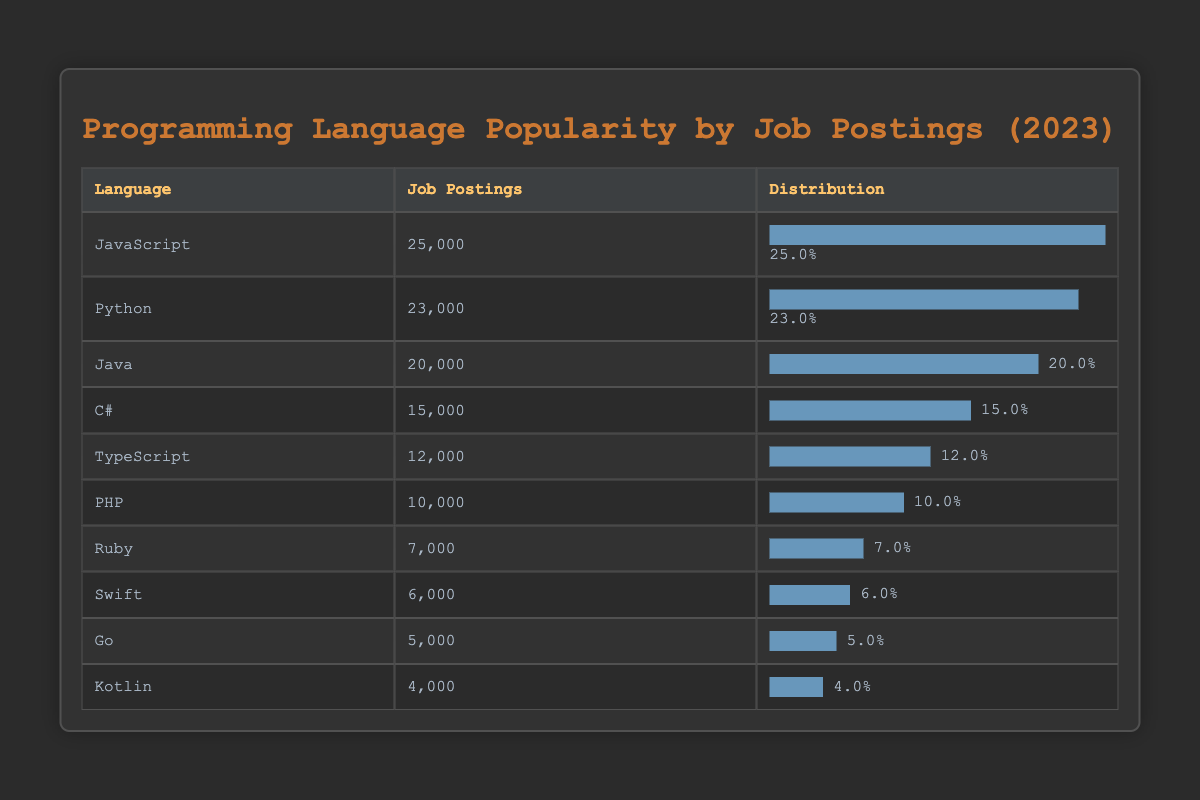What is the programming language with the most job postings? The table shows that JavaScript has 25,000 job postings, which is the highest among all listed languages.
Answer: JavaScript How many job postings are there for C#? The table displays that C# has 15,000 job postings.
Answer: 15,000 What is the difference in job postings between JavaScript and Python? JavaScript has 25,000 job postings, while Python has 23,000. The difference is calculated as 25,000 - 23,000 = 2,000.
Answer: 2,000 Is TypeScript more popular than PHP in terms of job postings? TypeScript has 12,000 job postings, while PHP has 10,000 job postings, indicating that TypeScript is indeed more popular.
Answer: Yes What percentage of the total job postings does Kotlin represent? The total job postings for all languages are 25000 + 23000 + 20000 + 15000 + 12000 + 10000 + 7000 + 6000 + 5000 + 4000 = 1,10,000. Kotlin has 4,000 job postings. The percentage is (4000 / 110000) * 100 = 3.64%.
Answer: 3.64% What is the average number of job postings for the top three programming languages? The top three languages by job postings are JavaScript (25,000), Python (23,000), and Java (20,000). To find the average, sum these values: 25,000 + 23,000 + 20,000 = 68,000. The average is 68,000 / 3 = 22,666.67.
Answer: 22,666.67 Which programming language has the least number of job postings? The table indicates that Kotlin has the least job postings, totaling 4,000.
Answer: Kotlin How many programming languages have more than 10,000 job postings? The languages with more than 10,000 job postings are JavaScript, Python, Java, C#, and TypeScript. Counting these, there are five languages, as PHP, Ruby, Swift, Go, and Kotlin fall below that threshold.
Answer: 5 Are there more job postings for Ruby than for Swift? Ruby has 7,000 job postings, while Swift has 6,000, which confirms that Ruby has more job postings.
Answer: Yes 